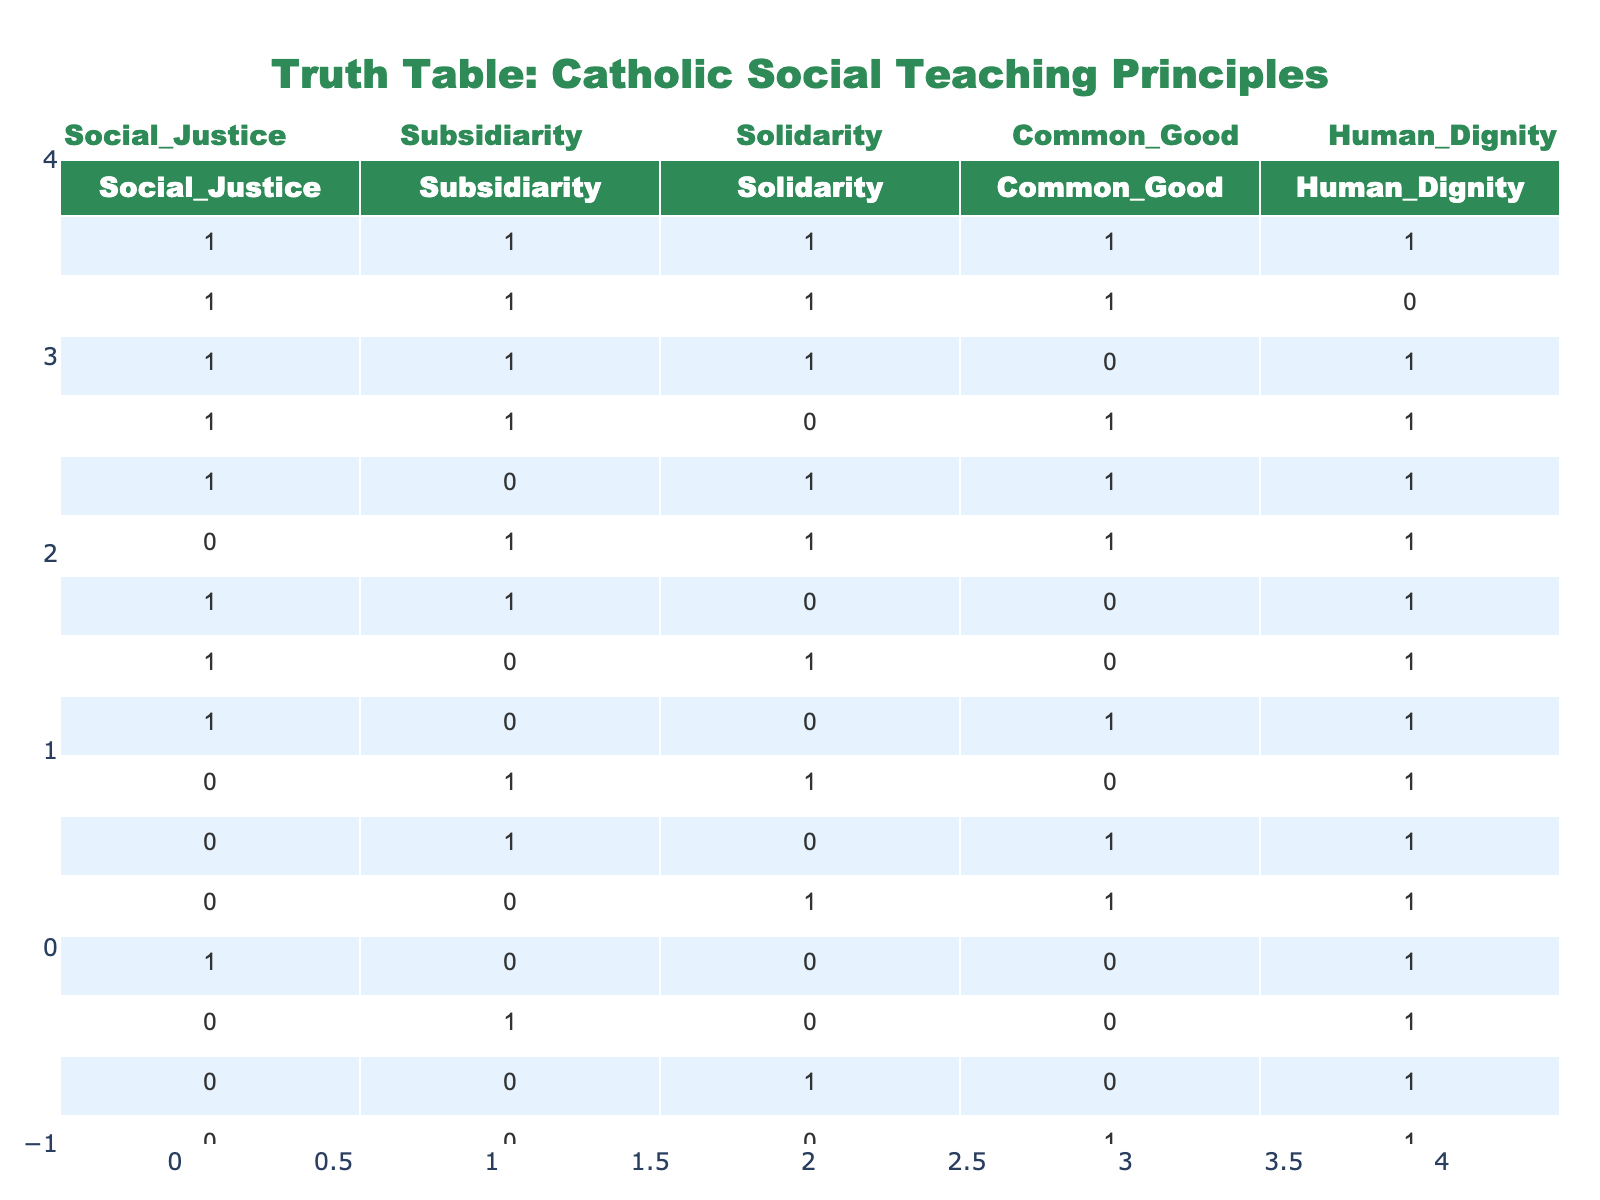What is the maximum value for Human Dignity? Looking at the table, the values for Human Dignity range from 0 to 1. The maximum value is easily identified as 1.
Answer: 1 How many rows have all principles (Social Justice, Subsidiarity, Solidarity, Common Good, Human Dignity) present? Upon checking the table, there is only 1 row with all principles (1s) present, which is the first row.
Answer: 1 What is the count of rows where Solidarity is 0? By inspecting the table, there are 7 rows where Solidarity has a value of 0, specifically rows 7 to 15.
Answer: 7 What is the total number of instances where both Social Justice and Common Good are 1? Analyzing the table, the rows that have both Social Justice and Common Good as 1 are rows 1, 2, 3, 4, and 5. Counting these gives a total of 5 instances.
Answer: 5 Is there any case where Human Dignity is 0 while all other principles are 1? Looking through the table, there are cases where Human Dignity is 0, but these cases do not have all other principles as 1. Therefore, the answer is no.
Answer: No What are the total rows with Common Good as 1? The total count of rows where Common Good is 1 can be found by systematically counting the 1s in that column. There are 8 such rows.
Answer: 8 Among those rows with Social Justice as 1, how many also have Human Dignity as 0? By checking the table, there are three rows where Social Justice is 1 and Human Dignity is 0; they are rows 2, 3 and 6.
Answer: 3 What is the average value of Subsidiarity across all rows? To find the average, we add up all the values of Subsidiarity (sum = 7) and divide by the total number of rows (15), resulting in an average of 7/15 = 0.4667.
Answer: 0.4667 